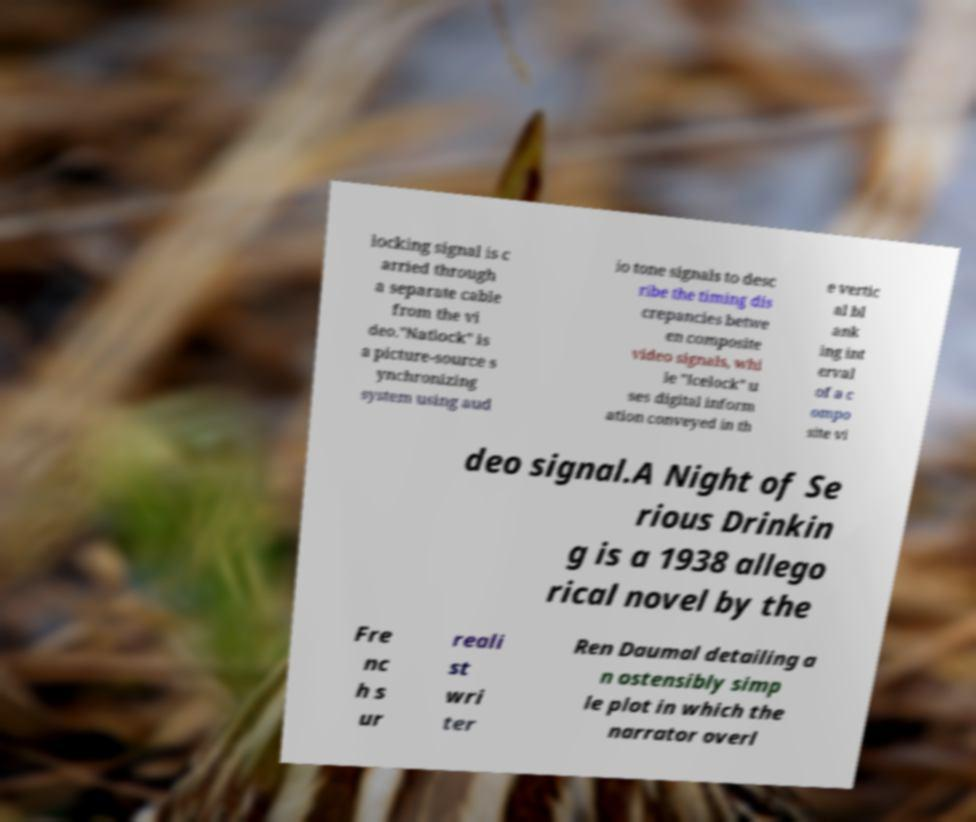What messages or text are displayed in this image? I need them in a readable, typed format. locking signal is c arried through a separate cable from the vi deo."Natlock" is a picture-source s ynchronizing system using aud io tone signals to desc ribe the timing dis crepancies betwe en composite video signals, whi le "Icelock" u ses digital inform ation conveyed in th e vertic al bl ank ing int erval of a c ompo site vi deo signal.A Night of Se rious Drinkin g is a 1938 allego rical novel by the Fre nc h s ur reali st wri ter Ren Daumal detailing a n ostensibly simp le plot in which the narrator overl 